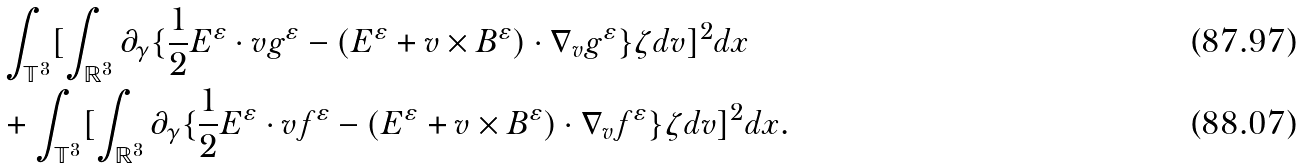Convert formula to latex. <formula><loc_0><loc_0><loc_500><loc_500>& \int _ { \mathbb { T } ^ { 3 } } [ \int _ { \mathbb { R } ^ { 3 } } \partial _ { \gamma } \{ \frac { 1 } { 2 } E ^ { \varepsilon } \cdot v g ^ { \varepsilon } - ( E ^ { \varepsilon } + v \times B ^ { \varepsilon } ) \cdot \nabla _ { v } g ^ { \varepsilon } \} \zeta d v ] ^ { 2 } d x \\ & + \int _ { \mathbb { T } ^ { 3 } } [ \int _ { \mathbb { R } ^ { 3 } } \partial _ { \gamma } \{ \frac { 1 } { 2 } E ^ { \varepsilon } \cdot v f ^ { \varepsilon } - ( E ^ { \varepsilon } + v \times B ^ { \varepsilon } ) \cdot \nabla _ { v } f ^ { \varepsilon } \} \zeta d v ] ^ { 2 } d x .</formula> 